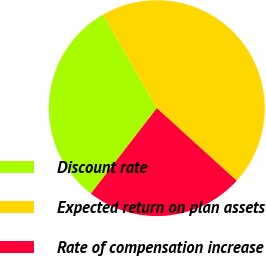<chart> <loc_0><loc_0><loc_500><loc_500><pie_chart><fcel>Discount rate<fcel>Expected return on plan assets<fcel>Rate of compensation increase<nl><fcel>31.23%<fcel>45.06%<fcel>23.72%<nl></chart> 